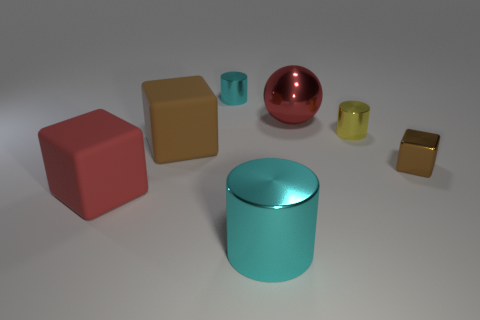What shape is the large cyan object?
Provide a short and direct response. Cylinder. How many cylinders are either large red shiny things or tiny brown metal things?
Your answer should be compact. 0. Are there the same number of big red matte things that are in front of the tiny cyan cylinder and small yellow cylinders that are on the left side of the large cyan cylinder?
Provide a succinct answer. No. There is a brown thing that is behind the small shiny thing that is in front of the yellow thing; what number of cyan things are behind it?
Ensure brevity in your answer.  1. What shape is the large matte object that is the same color as the shiny cube?
Ensure brevity in your answer.  Cube. There is a ball; is its color the same as the small metallic cylinder to the right of the big red ball?
Your answer should be very brief. No. Are there more large metallic cylinders that are behind the large red shiny thing than shiny blocks?
Your answer should be compact. No. How many objects are either metal cylinders that are to the left of the big sphere or large blocks that are behind the red cube?
Give a very brief answer. 3. There is another cube that is the same material as the big red cube; what size is it?
Provide a short and direct response. Large. There is a large red object behind the tiny brown metal block; does it have the same shape as the big cyan shiny thing?
Provide a succinct answer. No. 